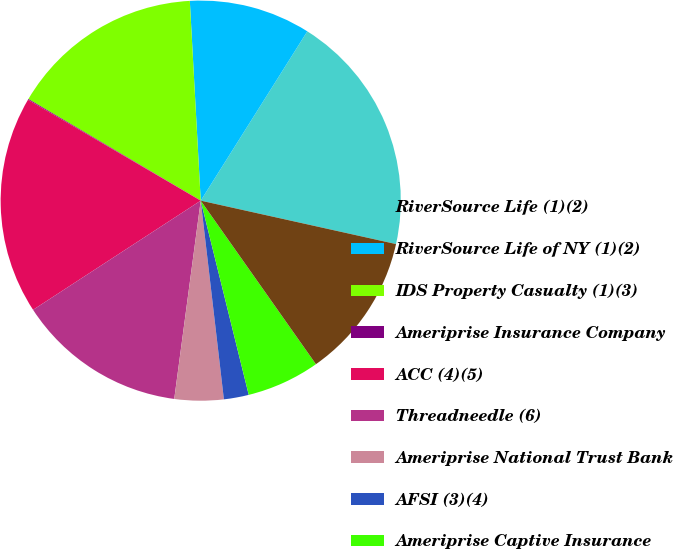Convert chart to OTSL. <chart><loc_0><loc_0><loc_500><loc_500><pie_chart><fcel>RiverSource Life (1)(2)<fcel>RiverSource Life of NY (1)(2)<fcel>IDS Property Casualty (1)(3)<fcel>Ameriprise Insurance Company<fcel>ACC (4)(5)<fcel>Threadneedle (6)<fcel>Ameriprise National Trust Bank<fcel>AFSI (3)(4)<fcel>Ameriprise Captive Insurance<fcel>Ameriprise Trust Company (3)<nl><fcel>19.54%<fcel>9.81%<fcel>15.65%<fcel>0.07%<fcel>17.6%<fcel>13.7%<fcel>3.96%<fcel>2.01%<fcel>5.91%<fcel>11.75%<nl></chart> 